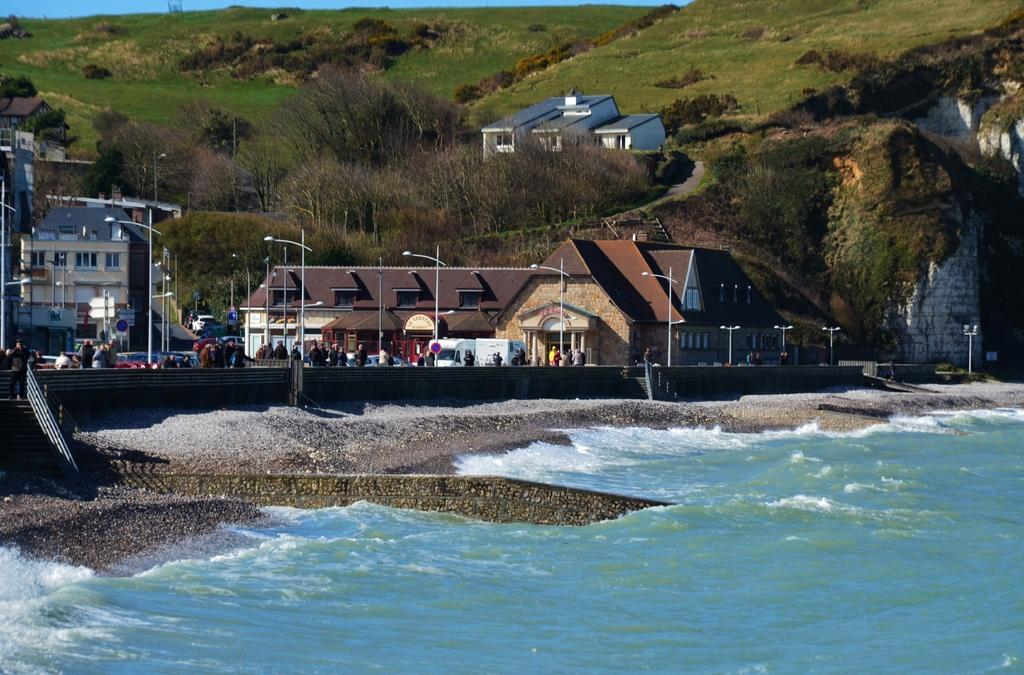What can be seen in the image that is related to infrastructure? There are pipes in the image. Who or what is present in the image besides the pipes? There is a group of people and vehicles visible in the image. What is the condition of the water in the image? Water is visible in the image. What can be seen in the distance in the image? There are buildings and trees in the background of the image. What type of flowers are being served by the servant in the image? There is no servant or flowers present in the image. 